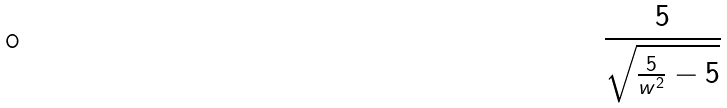Convert formula to latex. <formula><loc_0><loc_0><loc_500><loc_500>\frac { 5 } { \sqrt { \frac { 5 } { w ^ { 2 } } - 5 } }</formula> 